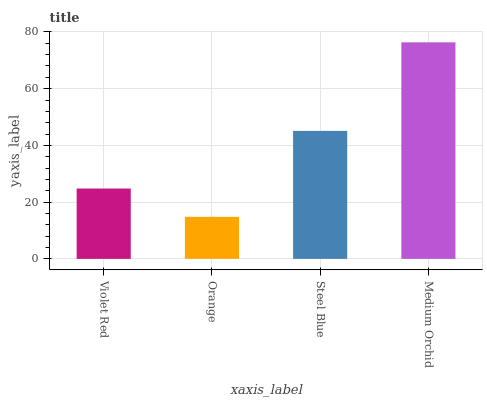Is Orange the minimum?
Answer yes or no. Yes. Is Medium Orchid the maximum?
Answer yes or no. Yes. Is Steel Blue the minimum?
Answer yes or no. No. Is Steel Blue the maximum?
Answer yes or no. No. Is Steel Blue greater than Orange?
Answer yes or no. Yes. Is Orange less than Steel Blue?
Answer yes or no. Yes. Is Orange greater than Steel Blue?
Answer yes or no. No. Is Steel Blue less than Orange?
Answer yes or no. No. Is Steel Blue the high median?
Answer yes or no. Yes. Is Violet Red the low median?
Answer yes or no. Yes. Is Violet Red the high median?
Answer yes or no. No. Is Orange the low median?
Answer yes or no. No. 